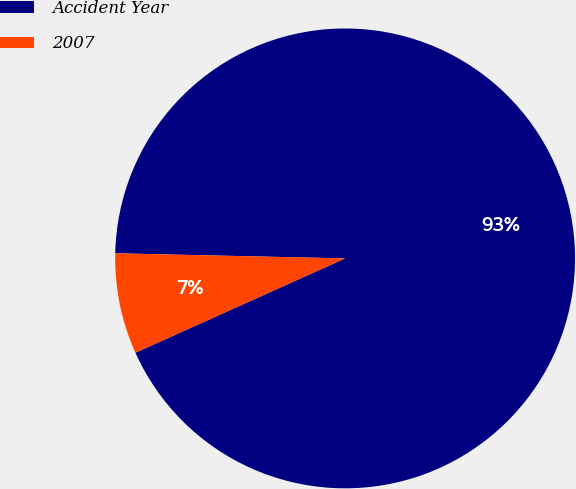Convert chart to OTSL. <chart><loc_0><loc_0><loc_500><loc_500><pie_chart><fcel>Accident Year<fcel>2007<nl><fcel>92.92%<fcel>7.08%<nl></chart> 